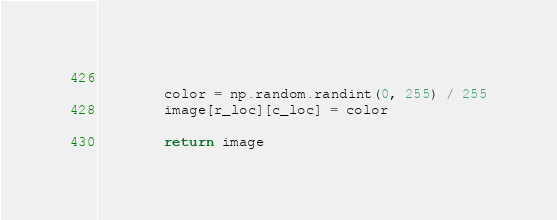Convert code to text. <code><loc_0><loc_0><loc_500><loc_500><_Python_>        
        color = np.random.randint(0, 255) / 255
        image[r_loc][c_loc] = color
        
        return image</code> 